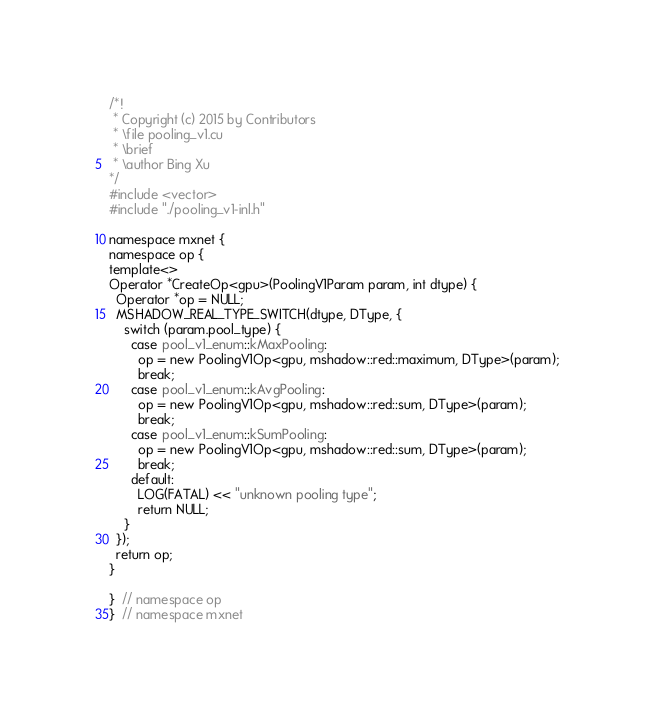<code> <loc_0><loc_0><loc_500><loc_500><_Cuda_>/*!
 * Copyright (c) 2015 by Contributors
 * \file pooling_v1.cu
 * \brief
 * \author Bing Xu
*/
#include <vector>
#include "./pooling_v1-inl.h"

namespace mxnet {
namespace op {
template<>
Operator *CreateOp<gpu>(PoolingV1Param param, int dtype) {
  Operator *op = NULL;
  MSHADOW_REAL_TYPE_SWITCH(dtype, DType, {
    switch (param.pool_type) {
      case pool_v1_enum::kMaxPooling:
        op = new PoolingV1Op<gpu, mshadow::red::maximum, DType>(param);
        break;
      case pool_v1_enum::kAvgPooling:
        op = new PoolingV1Op<gpu, mshadow::red::sum, DType>(param);
        break;
      case pool_v1_enum::kSumPooling:
        op = new PoolingV1Op<gpu, mshadow::red::sum, DType>(param);
        break;
      default:
        LOG(FATAL) << "unknown pooling type";
        return NULL;
    }
  });
  return op;
}

}  // namespace op
}  // namespace mxnet

</code> 